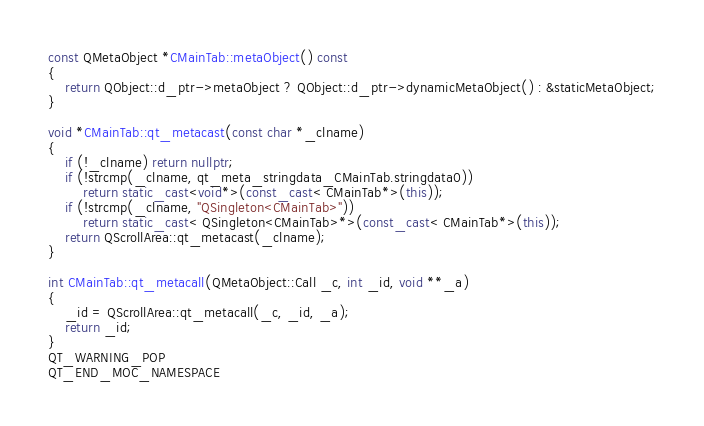<code> <loc_0><loc_0><loc_500><loc_500><_C++_>const QMetaObject *CMainTab::metaObject() const
{
    return QObject::d_ptr->metaObject ? QObject::d_ptr->dynamicMetaObject() : &staticMetaObject;
}

void *CMainTab::qt_metacast(const char *_clname)
{
    if (!_clname) return nullptr;
    if (!strcmp(_clname, qt_meta_stringdata_CMainTab.stringdata0))
        return static_cast<void*>(const_cast< CMainTab*>(this));
    if (!strcmp(_clname, "QSingleton<CMainTab>"))
        return static_cast< QSingleton<CMainTab>*>(const_cast< CMainTab*>(this));
    return QScrollArea::qt_metacast(_clname);
}

int CMainTab::qt_metacall(QMetaObject::Call _c, int _id, void **_a)
{
    _id = QScrollArea::qt_metacall(_c, _id, _a);
    return _id;
}
QT_WARNING_POP
QT_END_MOC_NAMESPACE
</code> 